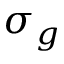<formula> <loc_0><loc_0><loc_500><loc_500>\sigma _ { g }</formula> 